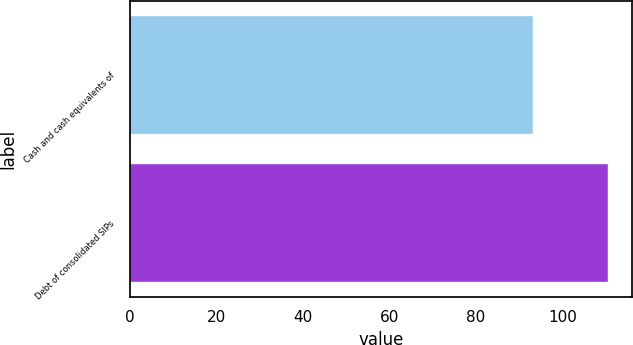<chart> <loc_0><loc_0><loc_500><loc_500><bar_chart><fcel>Cash and cash equivalents of<fcel>Debt of consolidated SIPs<nl><fcel>93.1<fcel>110.4<nl></chart> 